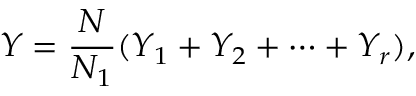Convert formula to latex. <formula><loc_0><loc_0><loc_500><loc_500>Y = { \frac { N } { N _ { 1 } } } ( Y _ { 1 } + Y _ { 2 } + \cdots + Y _ { r } ) ,</formula> 